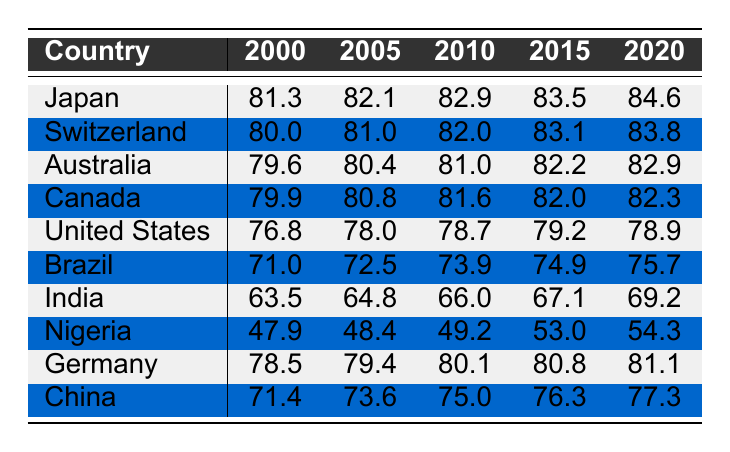What was the life expectancy in Japan in 2010? In the table, locate Japan’s row and check the value under the year 2010. The value is 82.9.
Answer: 82.9 Which country had the highest life expectancy in 2020? Comparing the values for each country in the year 2020, Japan has the highest value at 84.6.
Answer: Japan What is the difference in life expectancy between the United States and Canada in 2015? Look at the life expectancies for the United States and Canada in 2015, which are 79.2 and 82.0 respectively. The difference is calculated by subtracting: 82.0 - 79.2 = 2.8.
Answer: 2.8 Is the life expectancy in India higher than in Nigeria in 2020? Check the values for India and Nigeria in 2020; India has 69.2 and Nigeria has 54.3. Since 69.2 is greater than 54.3, the statement is true.
Answer: Yes What was the average life expectancy of Australia and Germany from 2000 to 2020? Calculate the total life expectancy over the years for both countries: Australia (79.6 + 80.4 + 81.0 + 82.2 + 82.9 = 406.1) and Germany (78.5 + 79.4 + 80.1 + 80.8 + 81.1 = 400.9). The average for both countries combined is (406.1 + 400.9) / 10 = 80.71.
Answer: 80.71 